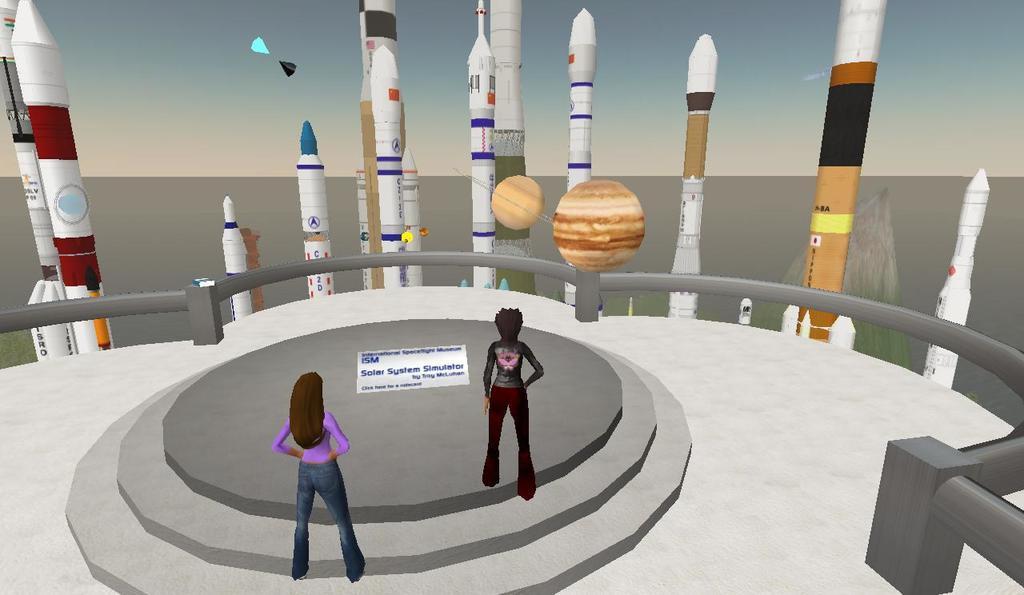Describe this image in one or two sentences. This is an animated picture, in this image we can see the person's, rockets and some other objects, in the background, we can see the sky. 